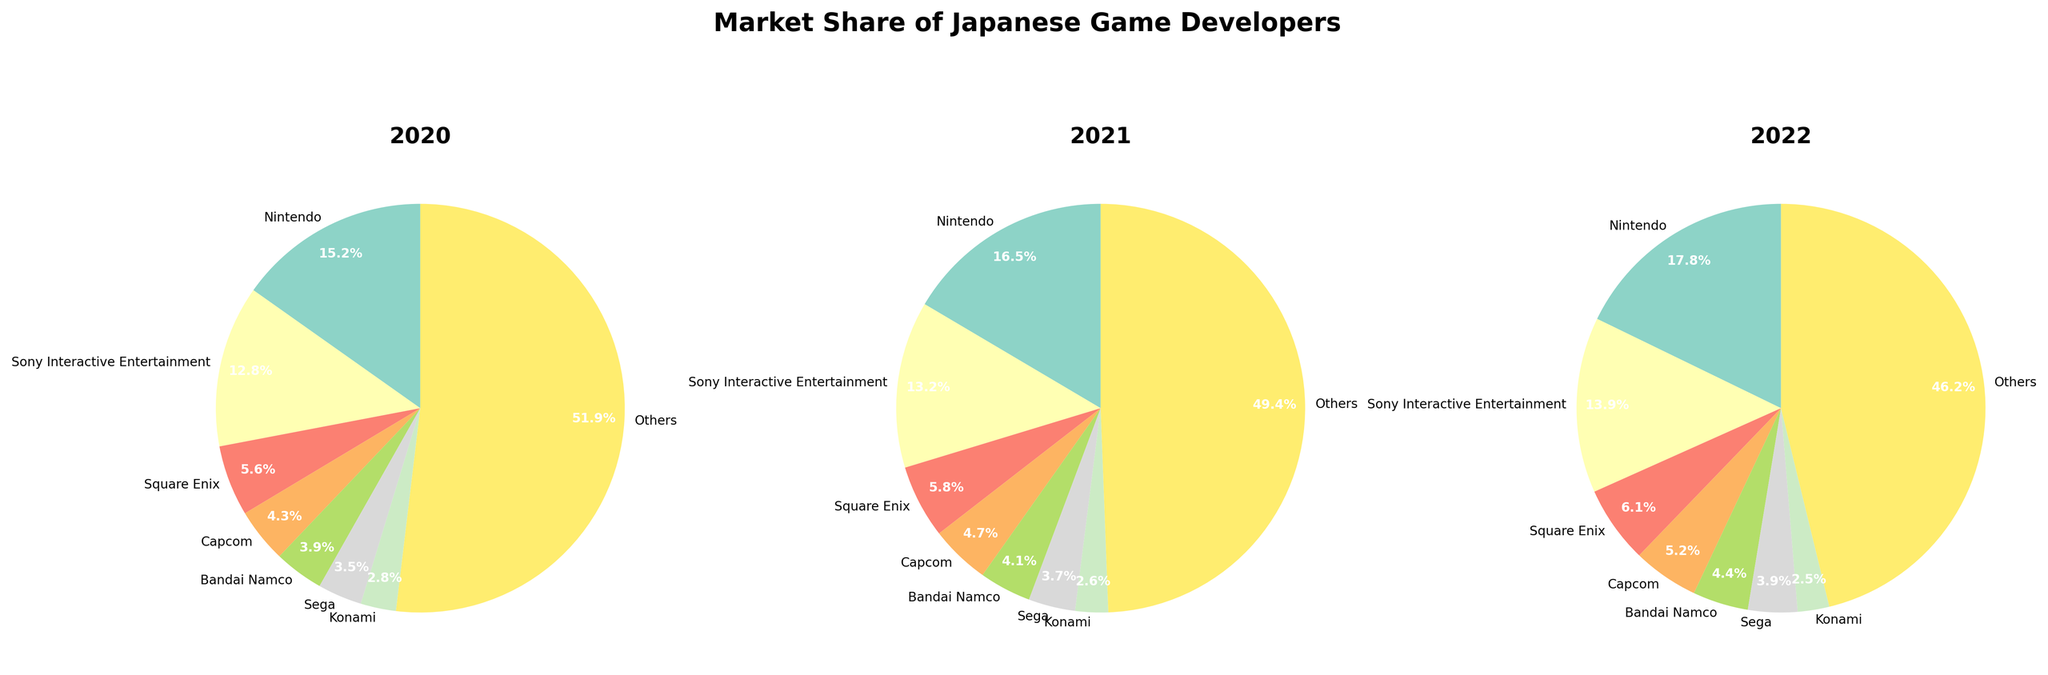What developer had the highest market share in 2022? By looking at the pie chart for 2022, we can see that Nintendo has the largest portion of the pie, indicating it has the highest market share.
Answer: Nintendo Which developer's market share increased the most from 2020 to 2022? Compare the market shares from 2020 to 2022 for each developer. Nintendo increased from 15.2% to 17.8%, which is an increase of 2.6%. This is the largest increase when compared to other developers.
Answer: Nintendo How did "Others" market share change over the years? By analyzing the different years, "Others" changed from 51.9% in 2020 to 49.4% in 2021, and then to 46.2% in 2022, which shows a continuous decrease over these years.
Answer: Decreased Which year did Sony Interactive Entertainment have the closest market share to Nintendo? By comparing the market shares of Sony Interactive Entertainment and Nintendo for each year, we see that in 2022, Sony had 13.9% and Nintendo had 17.8%, making this the year where the difference is smallest.
Answer: 2022 What is the combined market share of Square Enix and Capcom in 2020? Looking at the pie chart for 2020, Square Enix has a market share of 5.6% and Capcom has 4.3%. Adding these gives 5.6% + 4.3% = 9.9%.
Answer: 9.9% Did Sega's market share increase or decrease from 2020 to 2022? From the data, Sega's market share was 3.5% in 2020, 3.7% in 2021, and 3.9% in 2022. Therefore, it increased over these years.
Answer: Increased What is the difference in market share between the least and most dominant developers in 2021? In 2021, Nintendo had the highest market share at 16.5% and Konami had the lowest at 2.6%. The difference is 16.5% - 2.6% = 13.9%.
Answer: 13.9% If you were to combine Bandai Namco and Sega's market share, would they outperform Sony Interactive Entertainment in 2020? Bandai Namco had 3.9% and Sega had 3.5% in 2020, combined it's 3.9% + 3.5% = 7.4%. Sony Interactive Entertainment had 12.8%, so 7.4% does not outperform 12.8%.
Answer: No 